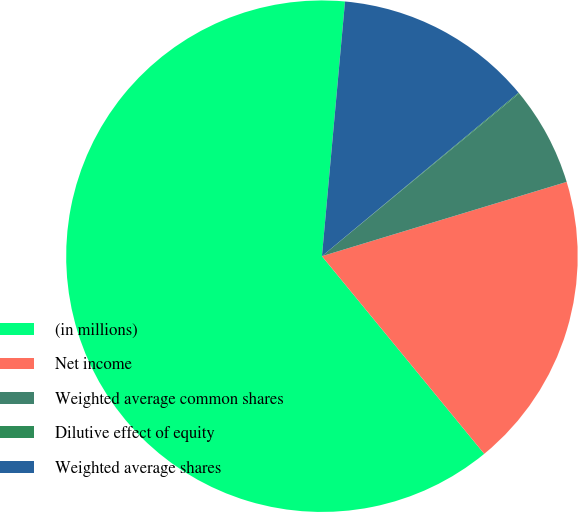Convert chart. <chart><loc_0><loc_0><loc_500><loc_500><pie_chart><fcel>(in millions)<fcel>Net income<fcel>Weighted average common shares<fcel>Dilutive effect of equity<fcel>Weighted average shares<nl><fcel>62.38%<fcel>18.75%<fcel>6.29%<fcel>0.06%<fcel>12.52%<nl></chart> 